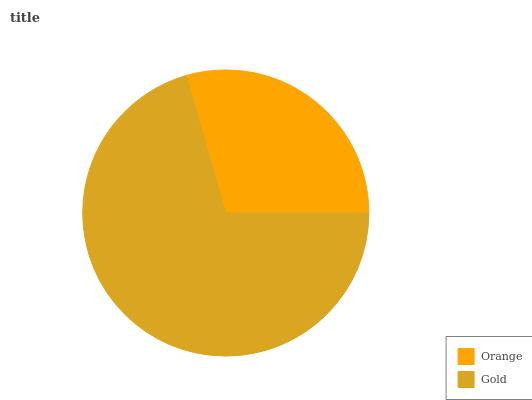Is Orange the minimum?
Answer yes or no. Yes. Is Gold the maximum?
Answer yes or no. Yes. Is Gold the minimum?
Answer yes or no. No. Is Gold greater than Orange?
Answer yes or no. Yes. Is Orange less than Gold?
Answer yes or no. Yes. Is Orange greater than Gold?
Answer yes or no. No. Is Gold less than Orange?
Answer yes or no. No. Is Gold the high median?
Answer yes or no. Yes. Is Orange the low median?
Answer yes or no. Yes. Is Orange the high median?
Answer yes or no. No. Is Gold the low median?
Answer yes or no. No. 